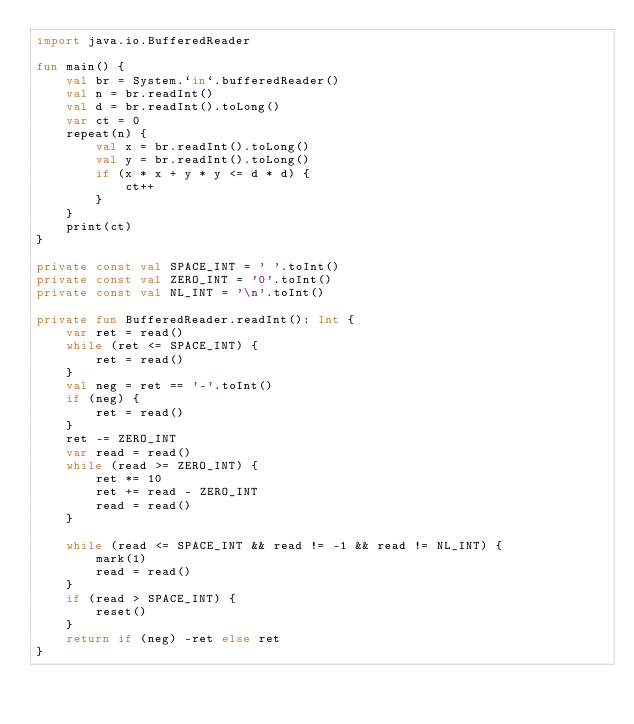Convert code to text. <code><loc_0><loc_0><loc_500><loc_500><_Kotlin_>import java.io.BufferedReader

fun main() {
    val br = System.`in`.bufferedReader()
    val n = br.readInt()
    val d = br.readInt().toLong()
    var ct = 0
    repeat(n) {
        val x = br.readInt().toLong()
        val y = br.readInt().toLong()
        if (x * x + y * y <= d * d) {
            ct++
        }
    }
    print(ct)
}

private const val SPACE_INT = ' '.toInt()
private const val ZERO_INT = '0'.toInt()
private const val NL_INT = '\n'.toInt()

private fun BufferedReader.readInt(): Int {
    var ret = read()
    while (ret <= SPACE_INT) {
        ret = read()
    }
    val neg = ret == '-'.toInt()
    if (neg) {
        ret = read()
    }
    ret -= ZERO_INT
    var read = read()
    while (read >= ZERO_INT) {
        ret *= 10
        ret += read - ZERO_INT
        read = read()
    }

    while (read <= SPACE_INT && read != -1 && read != NL_INT) {
        mark(1)
        read = read()
    }
    if (read > SPACE_INT) {
        reset()
    }
    return if (neg) -ret else ret
}</code> 